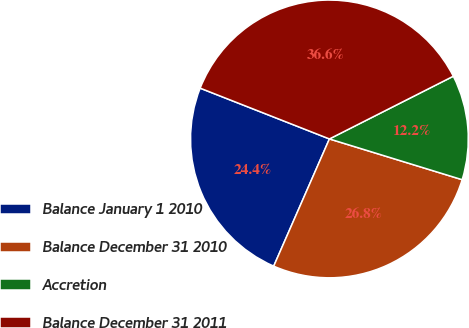Convert chart to OTSL. <chart><loc_0><loc_0><loc_500><loc_500><pie_chart><fcel>Balance January 1 2010<fcel>Balance December 31 2010<fcel>Accretion<fcel>Balance December 31 2011<nl><fcel>24.39%<fcel>26.83%<fcel>12.2%<fcel>36.59%<nl></chart> 